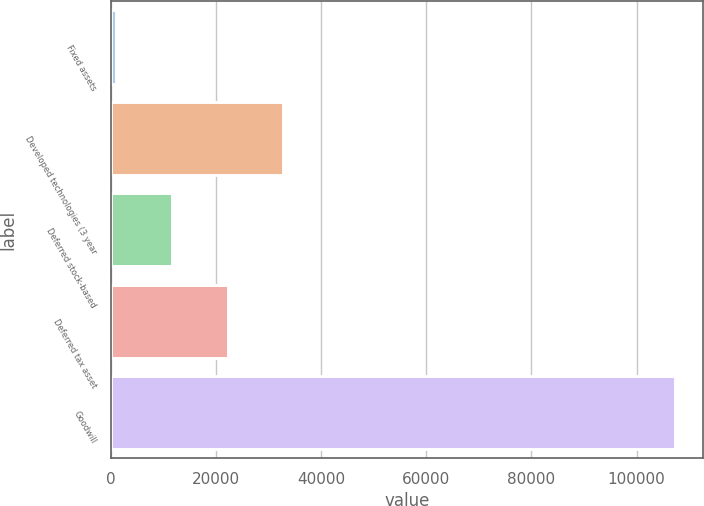Convert chart to OTSL. <chart><loc_0><loc_0><loc_500><loc_500><bar_chart><fcel>Fixed assets<fcel>Developed technologies (3 year<fcel>Deferred stock-based<fcel>Deferred tax asset<fcel>Goodwill<nl><fcel>921<fcel>32814.9<fcel>11552.3<fcel>22183.6<fcel>107234<nl></chart> 